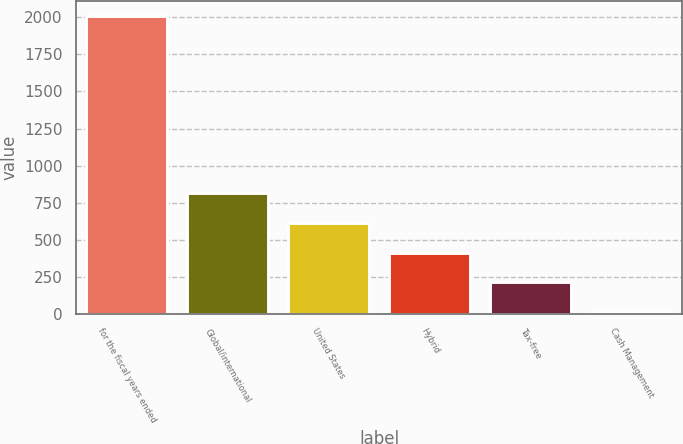Convert chart to OTSL. <chart><loc_0><loc_0><loc_500><loc_500><bar_chart><fcel>for the fiscal years ended<fcel>Global/international<fcel>United States<fcel>Hybrid<fcel>Tax-free<fcel>Cash Management<nl><fcel>2012<fcel>812.6<fcel>612.7<fcel>412.8<fcel>212.9<fcel>13<nl></chart> 